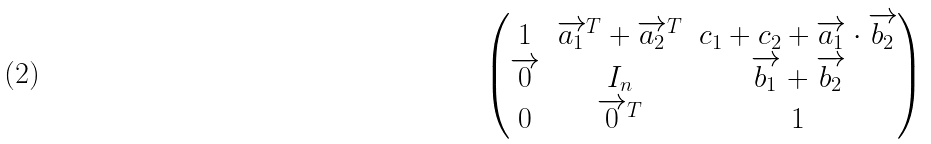Convert formula to latex. <formula><loc_0><loc_0><loc_500><loc_500>\begin{pmatrix} 1 & \overrightarrow { a _ { 1 } } ^ { T } + \overrightarrow { a _ { 2 } } ^ { T } & c _ { 1 } + c _ { 2 } + \overrightarrow { a _ { 1 } } \cdot \overrightarrow { b _ { 2 } } \\ \overrightarrow { 0 } & I _ { n } & \overrightarrow { b _ { 1 } } + \overrightarrow { b _ { 2 } } \\ 0 & \overrightarrow { 0 } ^ { T } & 1 \end{pmatrix}</formula> 